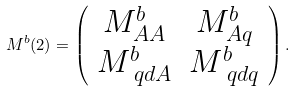Convert formula to latex. <formula><loc_0><loc_0><loc_500><loc_500>M ^ { b } ( 2 ) = \left ( \begin{array} { c c } M ^ { b } _ { A A } & M ^ { b } _ { A q } \\ M ^ { b } _ { \ q d A } & M ^ { b } _ { \ q d q } \end{array} \right ) .</formula> 